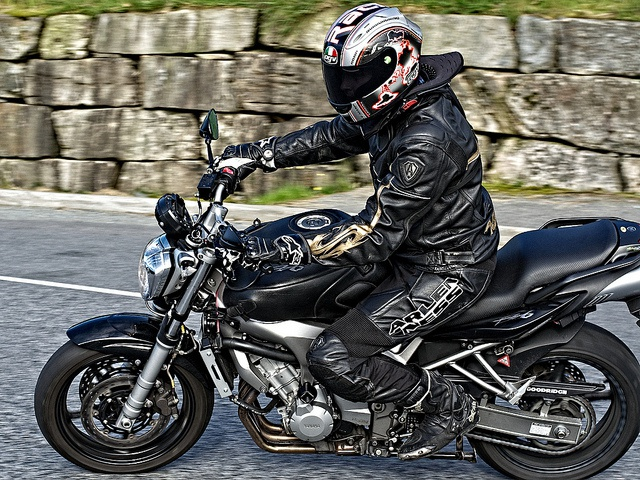Describe the objects in this image and their specific colors. I can see motorcycle in olive, black, gray, darkgray, and lightgray tones and people in olive, black, gray, white, and darkgray tones in this image. 